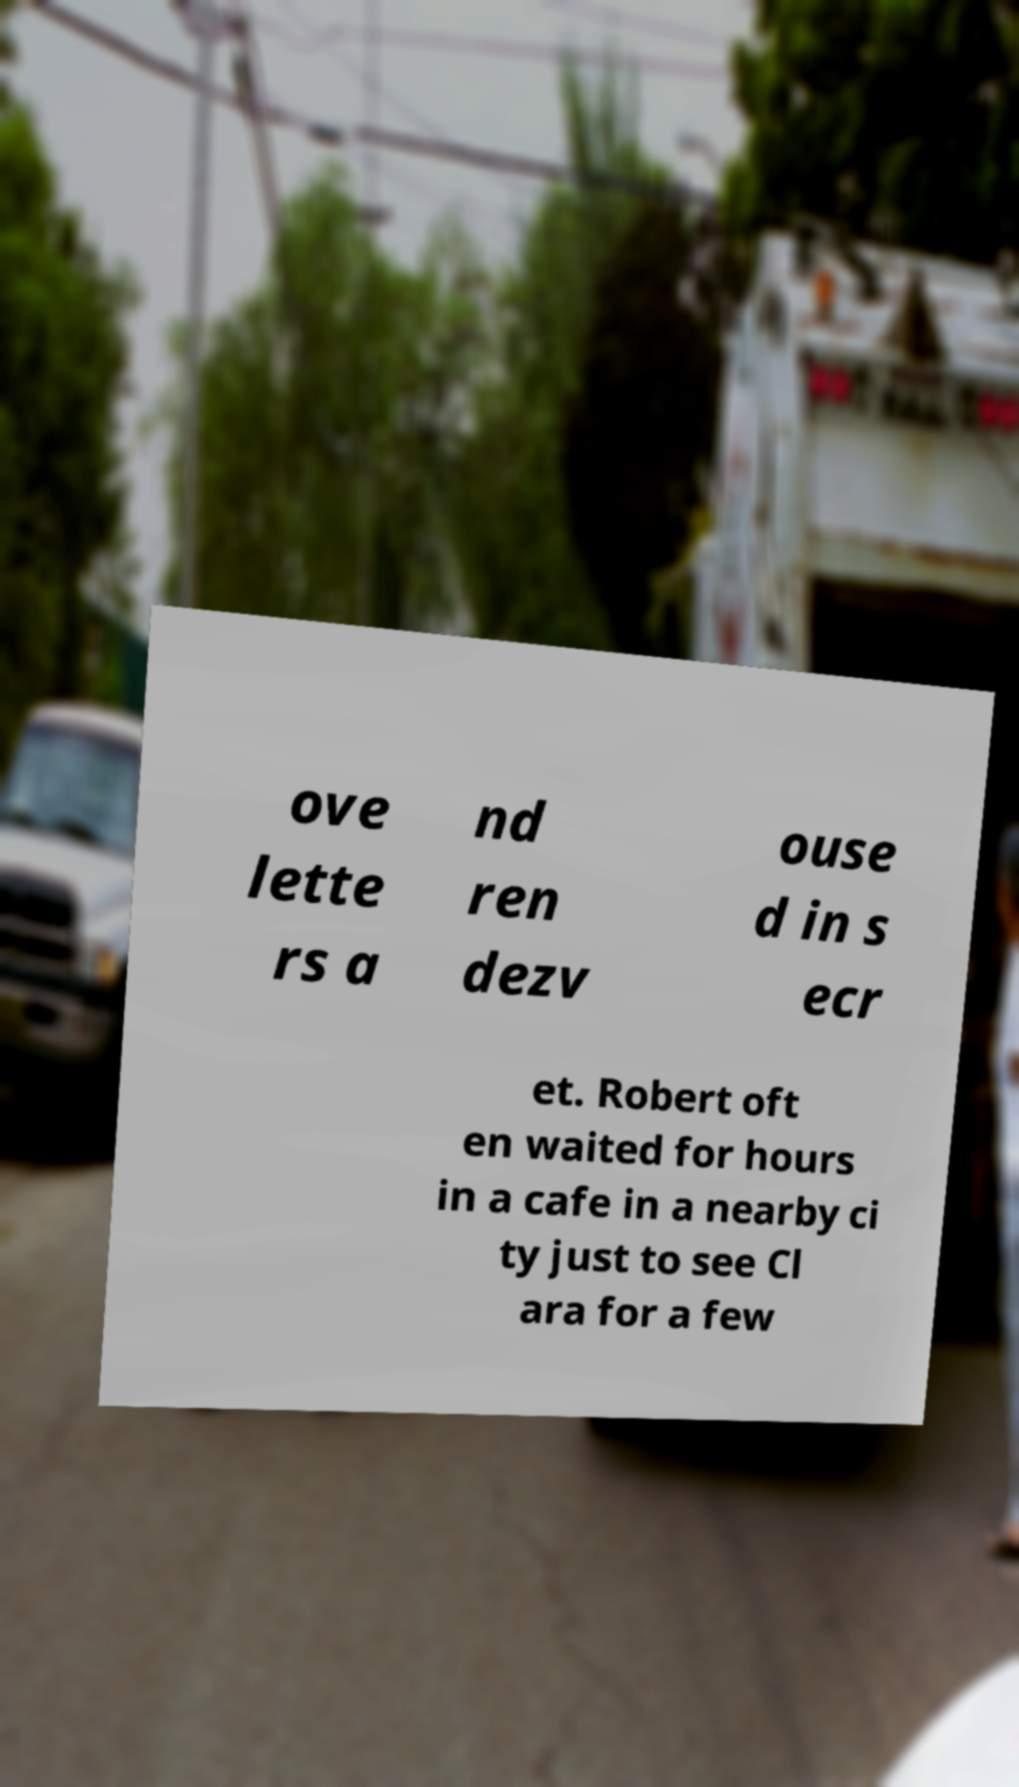There's text embedded in this image that I need extracted. Can you transcribe it verbatim? ove lette rs a nd ren dezv ouse d in s ecr et. Robert oft en waited for hours in a cafe in a nearby ci ty just to see Cl ara for a few 